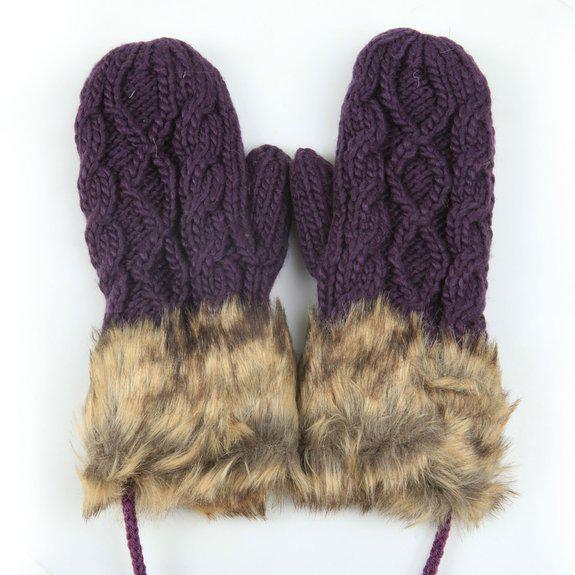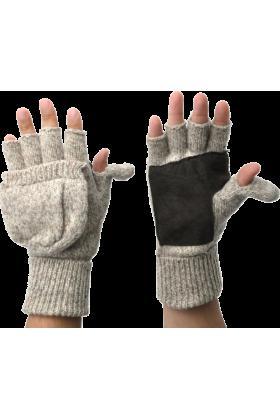The first image is the image on the left, the second image is the image on the right. Considering the images on both sides, is "Only one of the images shows convertible mittens." valid? Answer yes or no. Yes. The first image is the image on the left, the second image is the image on the right. Evaluate the accuracy of this statement regarding the images: "One image includes at least one pair of half-finger gloves with a mitten flap, and the other image shows one pair of knit mittens with fur cuffs at the wrists.". Is it true? Answer yes or no. Yes. 